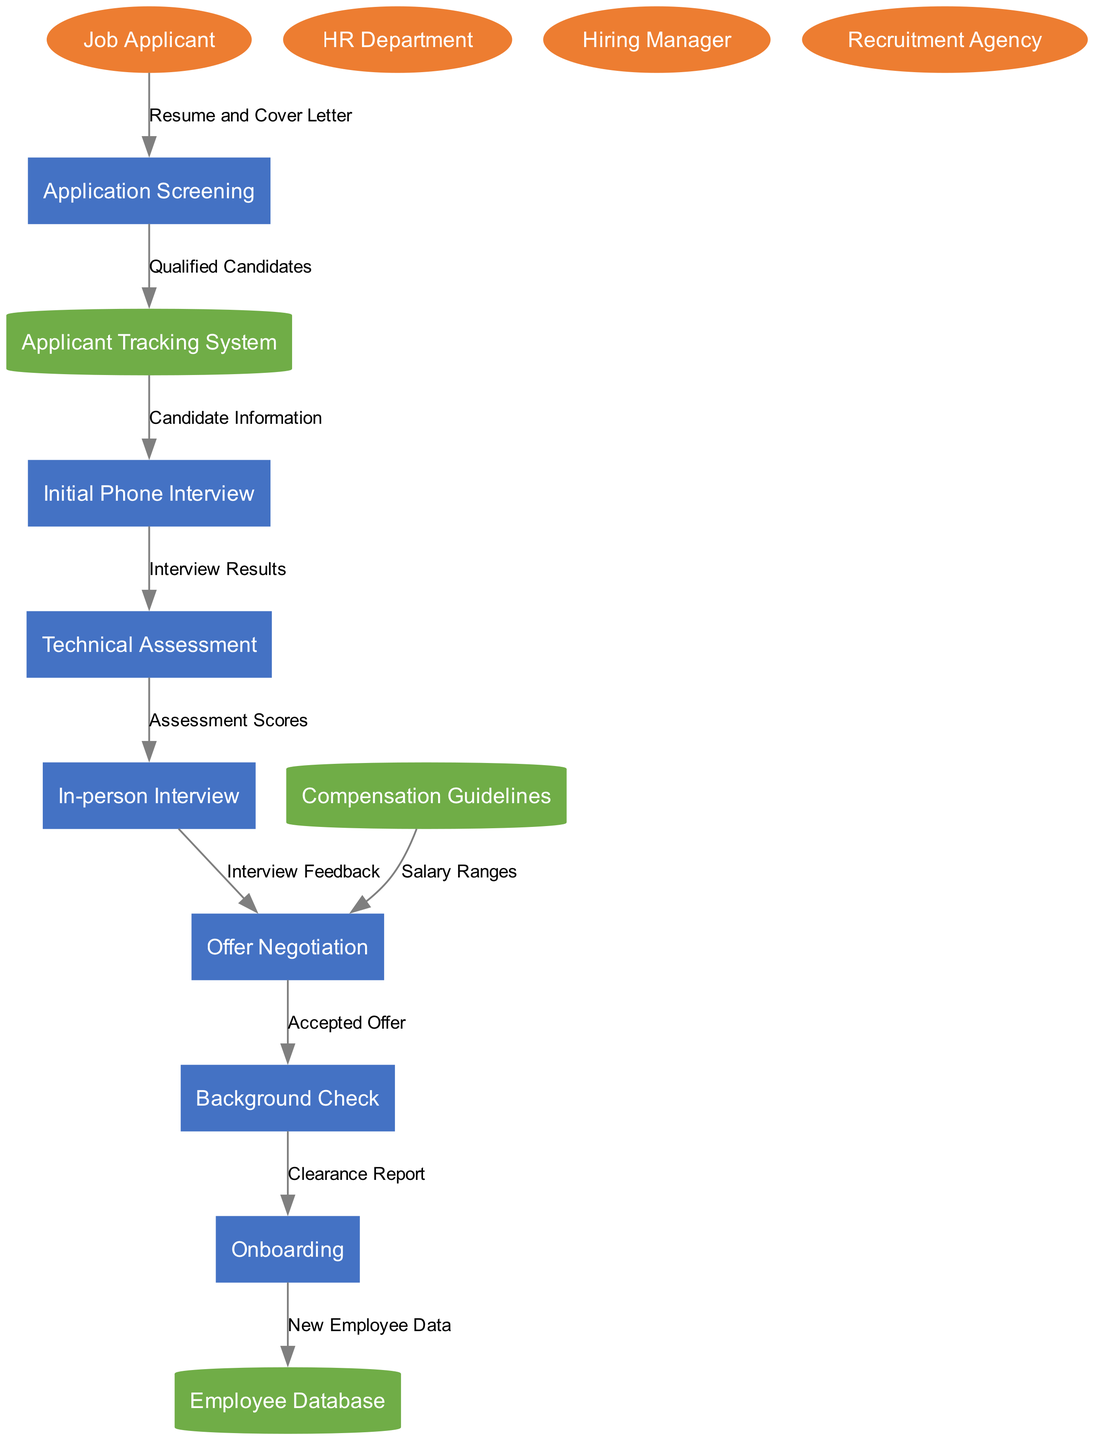What is the first process in the recruitment diagram? The first process in the diagram is "Application Screening." This can be confirmed by examining the flow of data starting from the "Job Applicant," which directly connects to "Application Screening."
Answer: Application Screening How many external entities are present in the diagram? The diagram includes four external entities: "Job Applicant," "HR Department," "Hiring Manager," and "Recruitment Agency." By counting these entities, we find the total.
Answer: Four What type of data is sent from "Job Applicant" to "Application Screening"? The data flowing from "Job Applicant" to "Application Screening" is labeled "Resume and Cover Letter." This label specifically indicates the information being shared at this initial step.
Answer: Resume and Cover Letter Which process receives data from "Compensation Guidelines"? The process that receives data from "Compensation Guidelines" is "Offer Negotiation." This is evident from the directed edge labeled "Salary Ranges" that illustrates the flow between these two nodes.
Answer: Offer Negotiation What is the final process that sends data to the data store? The final process that sends data to a data store is "Onboarding," which transmits "New Employee Data" to the "Employee Database." This shows the culmination of the recruitment process.
Answer: Onboarding Which two processes connect through "Interview Feedback"? The processes that are connected through "Interview Feedback" are "In-person Interview" and "Offer Negotiation." This connection can be traced by following the data flow labeled with this specific feedback.
Answer: In-person Interview and Offer Negotiation What is the purpose of the "Background Check" process in the sequence? The purpose of the "Background Check" process is to verify the "Accepted Offer" before moving on to "Onboarding." This is clear as it receives data specifically from the "Offer Negotiation" process.
Answer: Verify Accepted Offer How many processes are included in the recruitment diagram? The recruitment diagram comprises seven processes: "Application Screening," "Initial Phone Interview," "Technical Assessment," "In-person Interview," "Offer Negotiation," "Background Check," and "Onboarding." Counting these reveals the total number of processes involved.
Answer: Seven Which data store is connected to "Offer Negotiation"? The data store connected to "Offer Negotiation" is "Compensation Guidelines." The line connecting these two nodes illustrates the flow of salary ranges information needed for negotiation.
Answer: Compensation Guidelines 